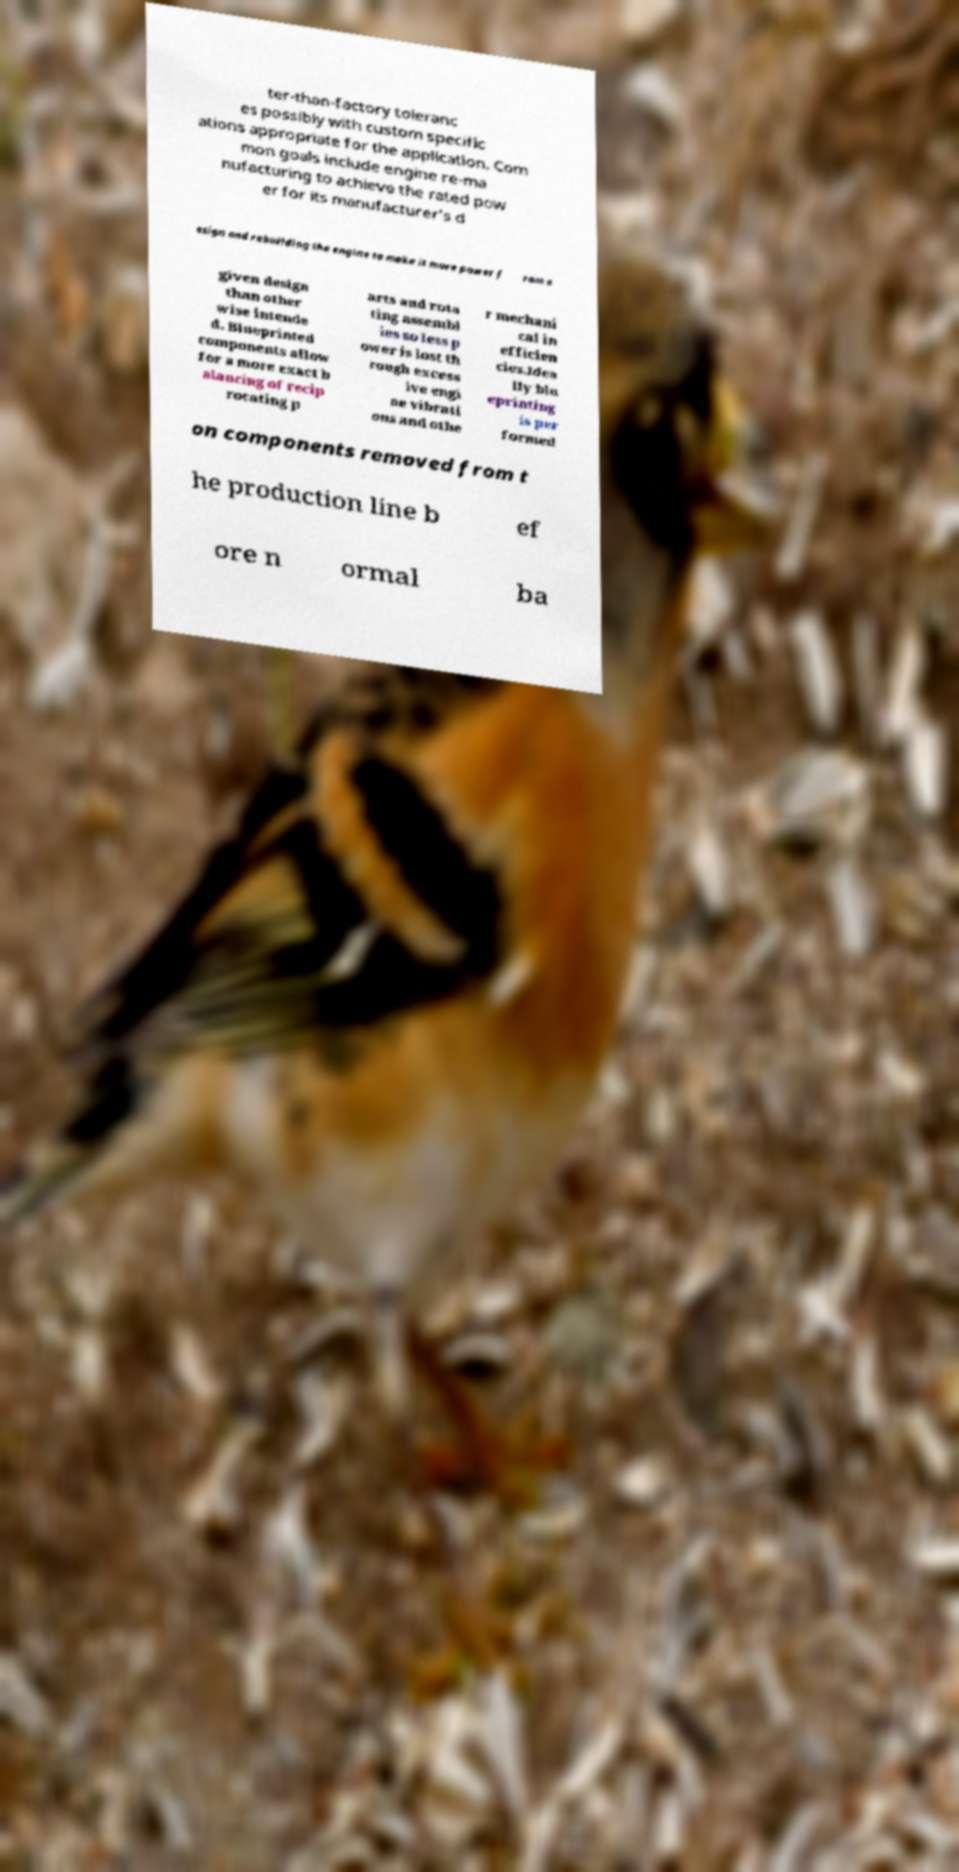Please read and relay the text visible in this image. What does it say? ter-than-factory toleranc es possibly with custom specific ations appropriate for the application. Com mon goals include engine re-ma nufacturing to achieve the rated pow er for its manufacturer's d esign and rebuilding the engine to make it more power f rom a given design than other wise intende d. Blueprinted components allow for a more exact b alancing of recip rocating p arts and rota ting assembl ies so less p ower is lost th rough excess ive engi ne vibrati ons and othe r mechani cal in efficien cies.Idea lly blu eprinting is per formed on components removed from t he production line b ef ore n ormal ba 